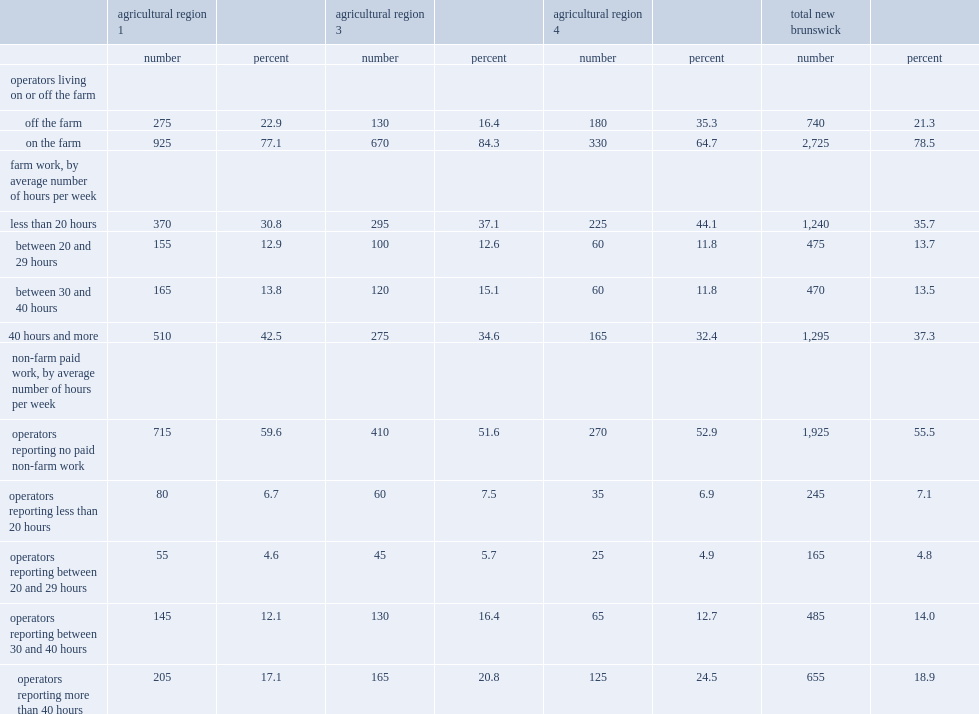Which agricultural region had more farm operators who were not not living on the farm, who declared working less than 20 hours per week on average on the farm, or working more than 40 hours per week on average in a paid non-agricultural job, compared with all farm operators in new brunswick? Agricultural region 4. Which agricultural region had a higher proportion of farm operators declaring having worked 40 hours or more per week on the farm,compared with all farm operators across new brunswick? Agricultural region 1. Which agricultural region had more farm operators who were more likely than all farm operators in new brunswick to live on farm. Agricultural region 3. 